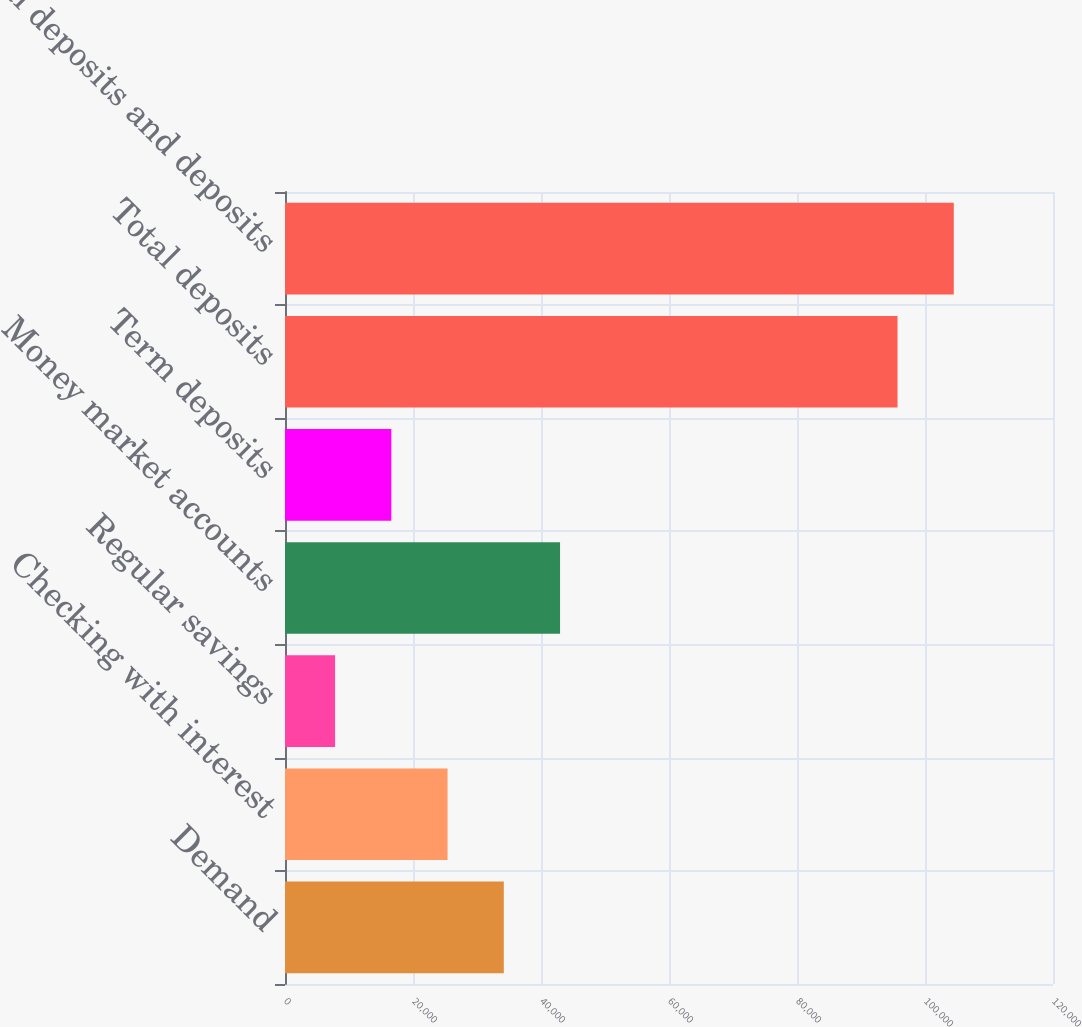Convert chart to OTSL. <chart><loc_0><loc_0><loc_500><loc_500><bar_chart><fcel>Demand<fcel>Checking with interest<fcel>Regular savings<fcel>Money market accounts<fcel>Term deposits<fcel>Total deposits<fcel>Total deposits and deposits<nl><fcel>34188.9<fcel>25400.6<fcel>7824<fcel>42977.2<fcel>16612.3<fcel>95707<fcel>104495<nl></chart> 